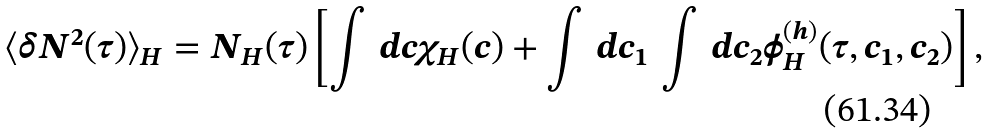<formula> <loc_0><loc_0><loc_500><loc_500>\langle \delta N ^ { 2 } ( \tau ) \rangle _ { H } = N _ { H } ( \tau ) \left [ \int \, d c \chi _ { H } ( c ) + \int \, d c _ { 1 } \, \int \, d c _ { 2 } \phi _ { H } ^ { ( h ) } ( \tau , c _ { 1 } , c _ { 2 } ) \right ] ,</formula> 